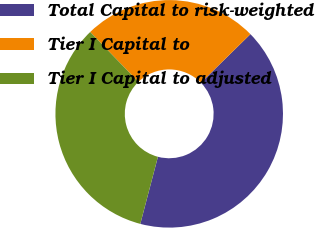<chart> <loc_0><loc_0><loc_500><loc_500><pie_chart><fcel>Total Capital to risk-weighted<fcel>Tier I Capital to<fcel>Tier I Capital to adjusted<nl><fcel>41.44%<fcel>24.87%<fcel>33.69%<nl></chart> 